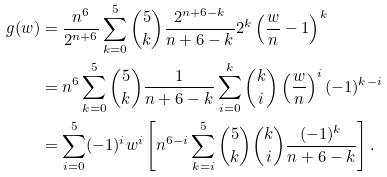<formula> <loc_0><loc_0><loc_500><loc_500>g ( w ) & = \frac { n ^ { 6 } } { 2 ^ { n + 6 } } \sum _ { k = 0 } ^ { 5 } \binom { 5 } { k } \frac { 2 ^ { n + 6 - k } } { n + 6 - k } 2 ^ { k } \left ( \frac { w } { n } - 1 \right ) ^ { k } \\ & = n ^ { 6 } \sum _ { k = 0 } ^ { 5 } \binom { 5 } { k } \frac { 1 } { n + 6 - k } \sum _ { i = 0 } ^ { k } \binom { k } { i } \left ( \frac { w } { n } \right ) ^ { i } ( - 1 ) ^ { k - i } \\ & = \sum _ { i = 0 } ^ { 5 } ( - 1 ) ^ { i } w ^ { i } \left [ n ^ { 6 - i } \sum _ { k = i } ^ { 5 } \binom { 5 } { k } \binom { k } { i } \frac { ( - 1 ) ^ { k } } { n + 6 - k } \right ] .</formula> 